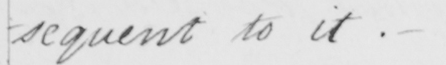What does this handwritten line say? -sequent to it . 